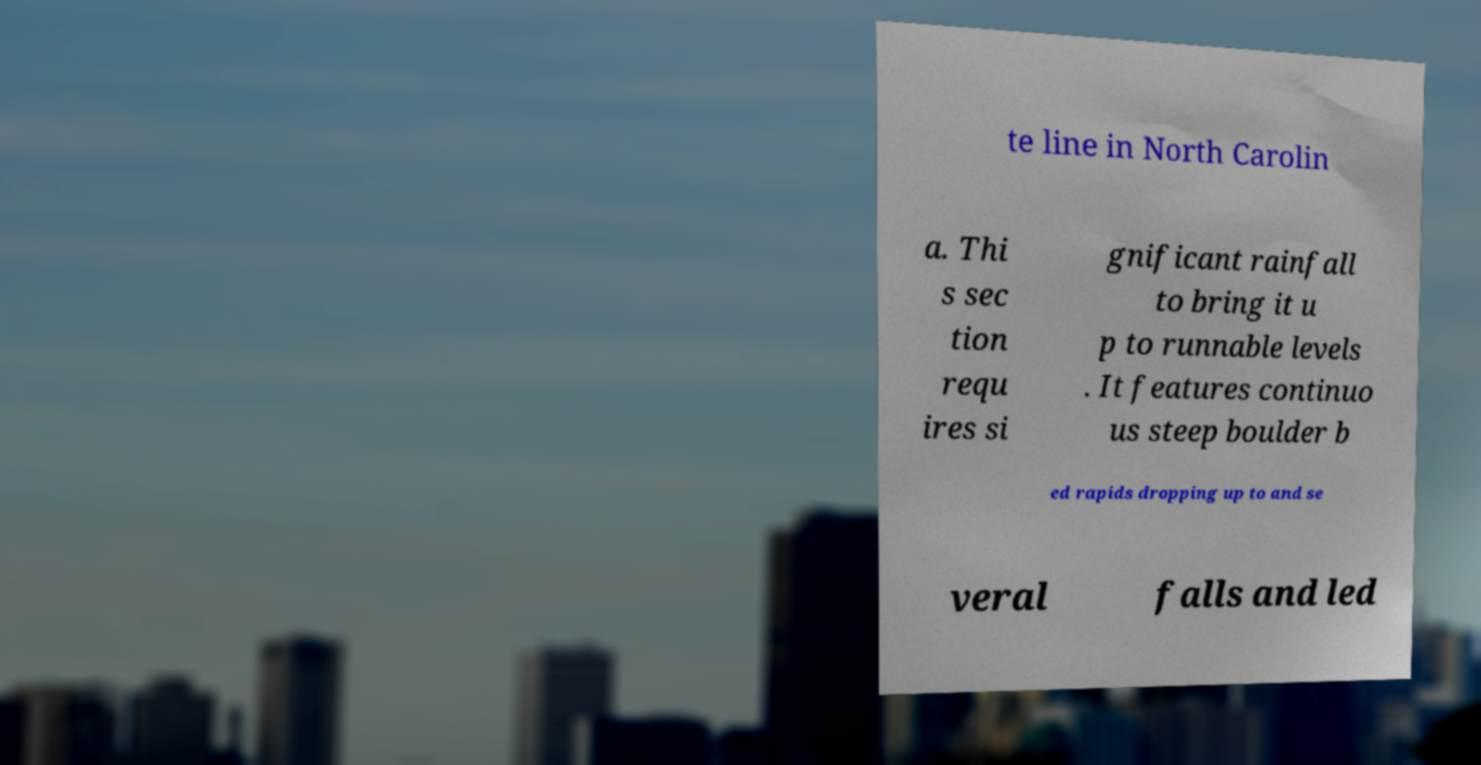Can you read and provide the text displayed in the image?This photo seems to have some interesting text. Can you extract and type it out for me? te line in North Carolin a. Thi s sec tion requ ires si gnificant rainfall to bring it u p to runnable levels . It features continuo us steep boulder b ed rapids dropping up to and se veral falls and led 